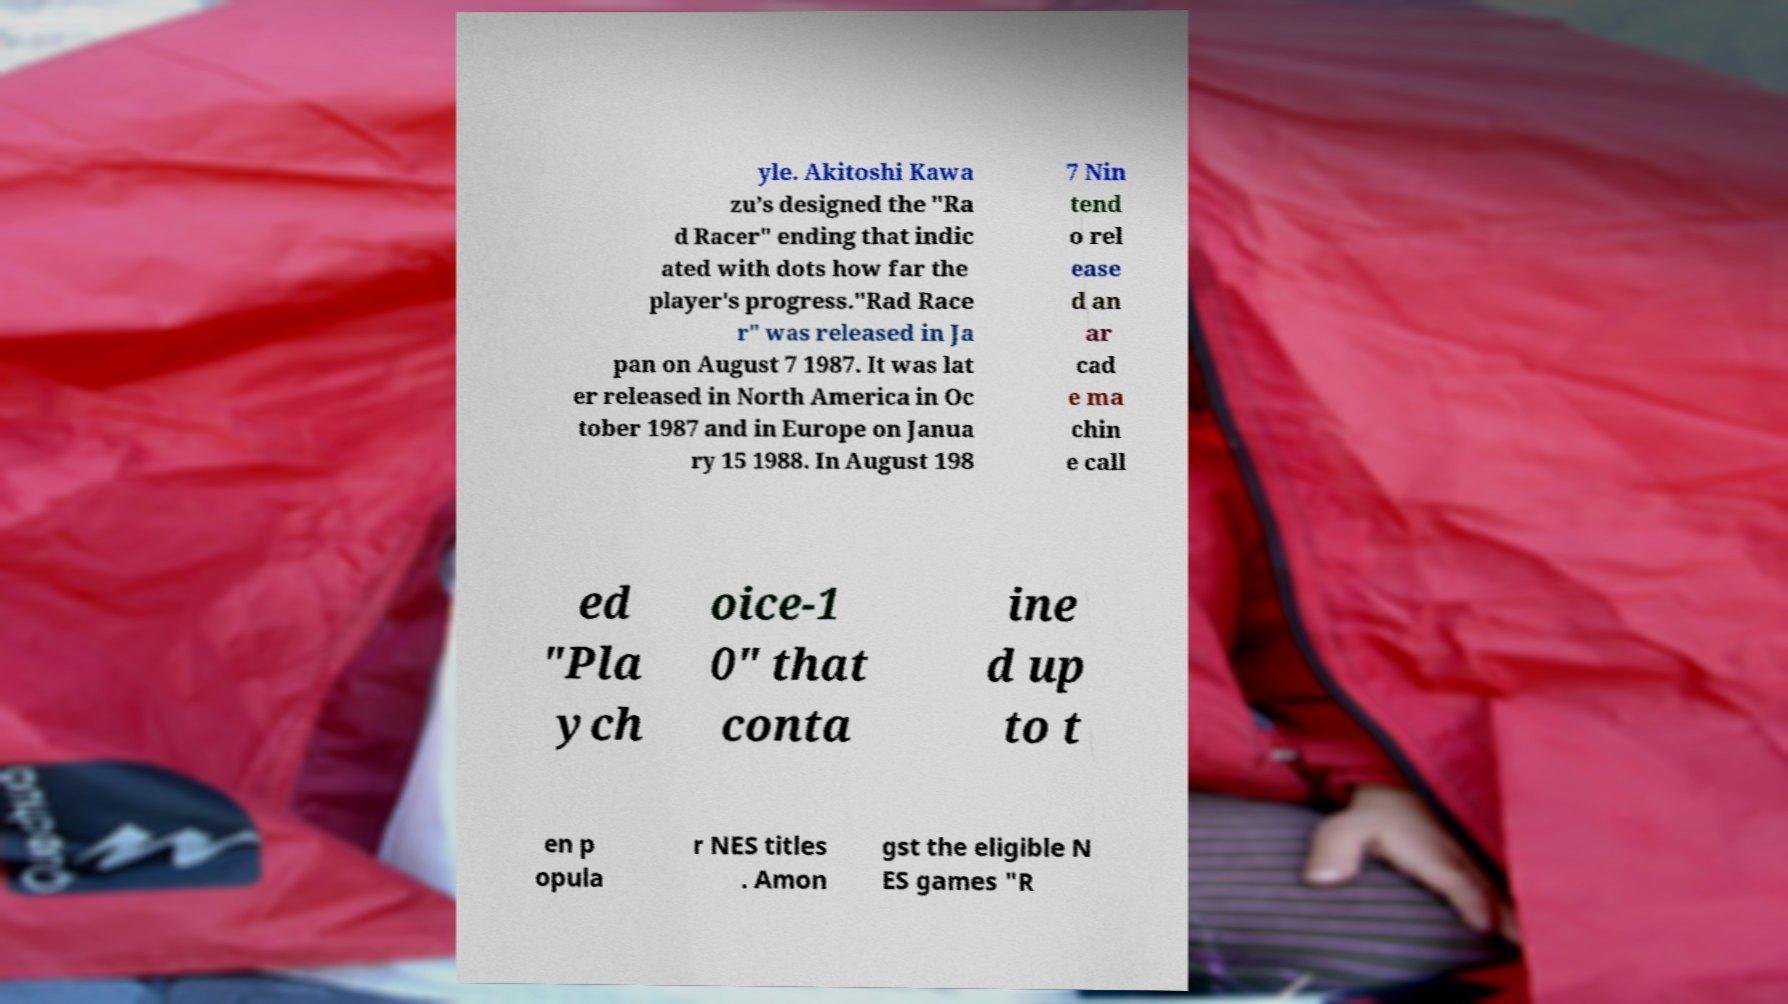There's text embedded in this image that I need extracted. Can you transcribe it verbatim? yle. Akitoshi Kawa zu’s designed the "Ra d Racer" ending that indic ated with dots how far the player's progress."Rad Race r" was released in Ja pan on August 7 1987. It was lat er released in North America in Oc tober 1987 and in Europe on Janua ry 15 1988. In August 198 7 Nin tend o rel ease d an ar cad e ma chin e call ed "Pla ych oice-1 0" that conta ine d up to t en p opula r NES titles . Amon gst the eligible N ES games "R 